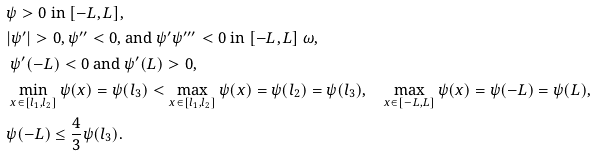<formula> <loc_0><loc_0><loc_500><loc_500>& \text {$\psi > 0$ in $[-L,L],$} \\ & \text {$|\psi^{\prime}|> 0, \psi^{\prime\prime}< 0$, and $\psi^{\prime}\psi^{\prime\prime\prime}< 0$ in $[-L, L] \ \omega,$} \\ & \text { $\psi^{\prime}(-L) < 0$ and $\psi^{\prime}(L) > 0,$} \\ & \text { $\min_{x \in [l_{1},l_{2}]}\psi(x)=\psi (l_{3}) < \max_{x\in [l_{1},l_{2}]}\psi(x)=\psi(l_{2})=\psi(l_{3}), \quad \max_{x\in[-L,L]}\psi(x)=\psi(-L)=\psi(L),$} \\ & \text {$\psi(-L)\leq \frac{4}{3}\psi(l_{3}).$}</formula> 